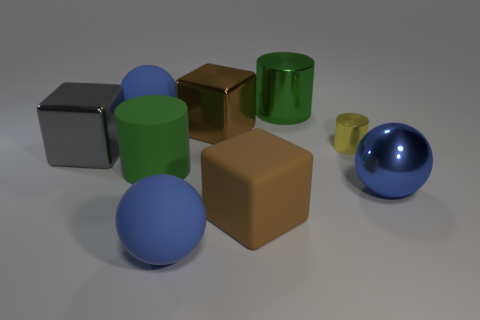Subtract 1 cubes. How many cubes are left? 2 Subtract all big matte spheres. How many spheres are left? 1 Add 1 big cylinders. How many objects exist? 10 Subtract all cylinders. How many objects are left? 6 Subtract 0 cyan cylinders. How many objects are left? 9 Subtract all rubber balls. Subtract all big blue balls. How many objects are left? 4 Add 2 rubber cylinders. How many rubber cylinders are left? 3 Add 2 tiny cyan blocks. How many tiny cyan blocks exist? 2 